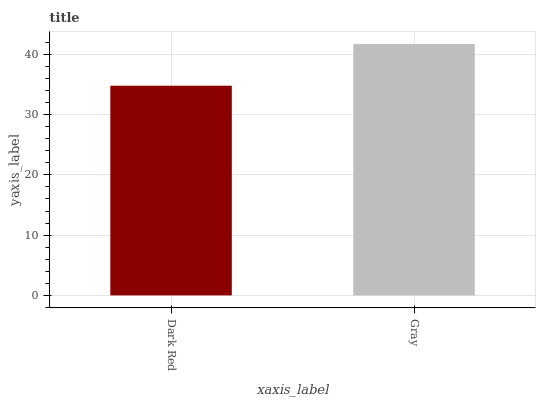Is Dark Red the minimum?
Answer yes or no. Yes. Is Gray the maximum?
Answer yes or no. Yes. Is Gray the minimum?
Answer yes or no. No. Is Gray greater than Dark Red?
Answer yes or no. Yes. Is Dark Red less than Gray?
Answer yes or no. Yes. Is Dark Red greater than Gray?
Answer yes or no. No. Is Gray less than Dark Red?
Answer yes or no. No. Is Gray the high median?
Answer yes or no. Yes. Is Dark Red the low median?
Answer yes or no. Yes. Is Dark Red the high median?
Answer yes or no. No. Is Gray the low median?
Answer yes or no. No. 